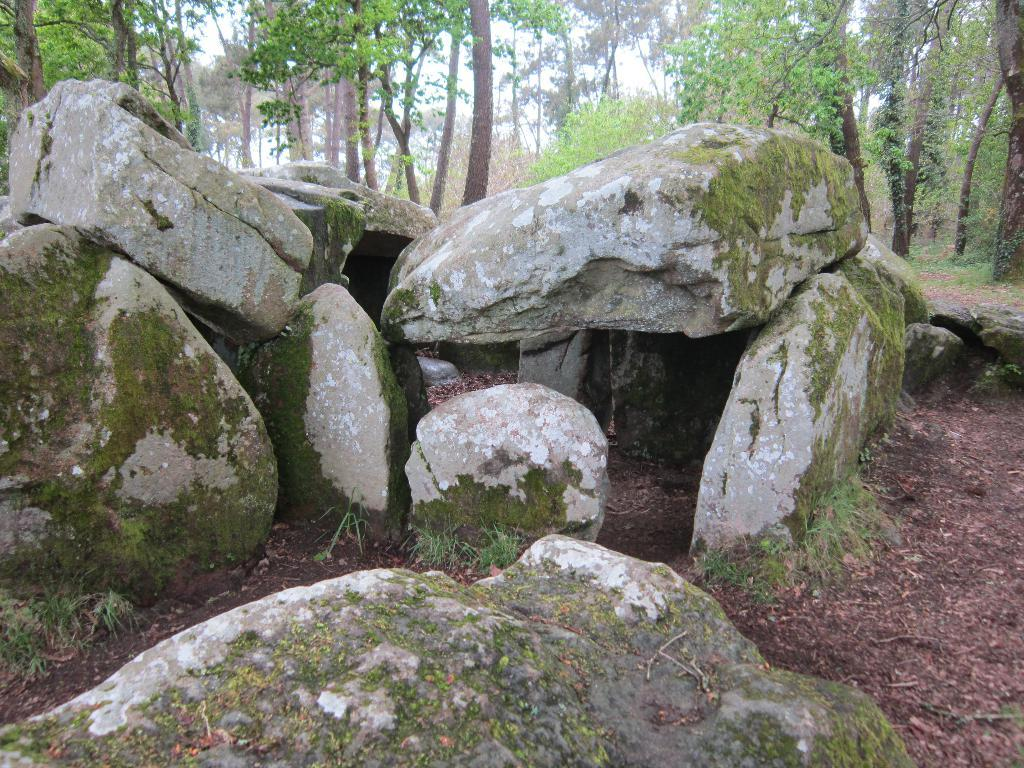What type of objects can be seen in the image? There are stones in the image. What can be seen in the distance in the image? There are trees in the background of the image. What type of behavior can be observed in the stones in the image? The stones do not exhibit any behavior, as they are inanimate objects. 